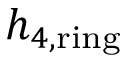<formula> <loc_0><loc_0><loc_500><loc_500>h _ { 4 , r i n g }</formula> 